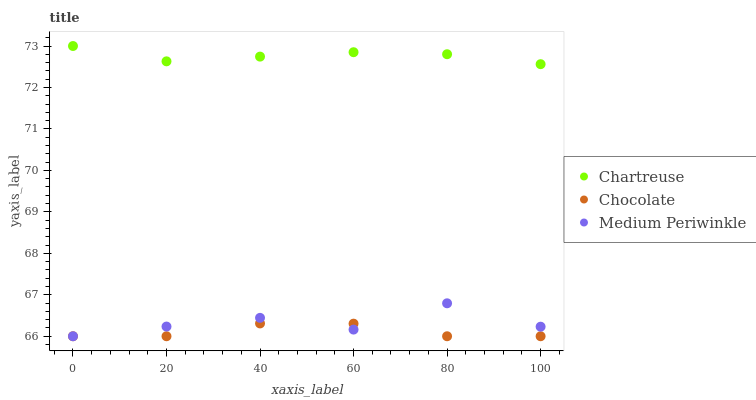Does Chocolate have the minimum area under the curve?
Answer yes or no. Yes. Does Chartreuse have the maximum area under the curve?
Answer yes or no. Yes. Does Medium Periwinkle have the minimum area under the curve?
Answer yes or no. No. Does Medium Periwinkle have the maximum area under the curve?
Answer yes or no. No. Is Chartreuse the smoothest?
Answer yes or no. Yes. Is Medium Periwinkle the roughest?
Answer yes or no. Yes. Is Chocolate the smoothest?
Answer yes or no. No. Is Chocolate the roughest?
Answer yes or no. No. Does Medium Periwinkle have the lowest value?
Answer yes or no. Yes. Does Chartreuse have the highest value?
Answer yes or no. Yes. Does Medium Periwinkle have the highest value?
Answer yes or no. No. Is Chocolate less than Chartreuse?
Answer yes or no. Yes. Is Chartreuse greater than Chocolate?
Answer yes or no. Yes. Does Chocolate intersect Medium Periwinkle?
Answer yes or no. Yes. Is Chocolate less than Medium Periwinkle?
Answer yes or no. No. Is Chocolate greater than Medium Periwinkle?
Answer yes or no. No. Does Chocolate intersect Chartreuse?
Answer yes or no. No. 